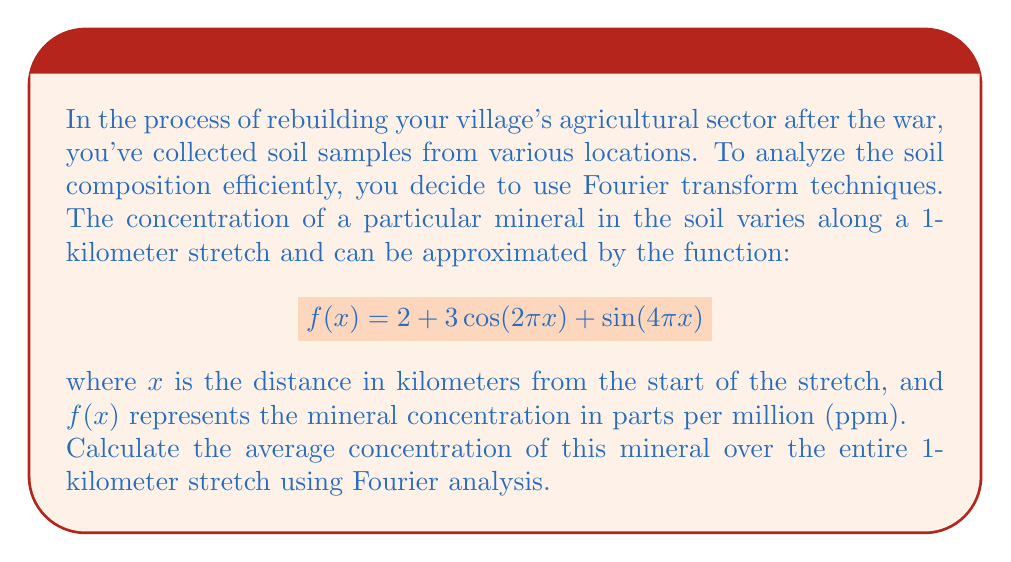Provide a solution to this math problem. To solve this problem, we'll use the properties of Fourier series and the fact that the average value of a function over its period is equal to its constant term (a₀) in the Fourier series.

1) First, let's identify the components of our function:
   $$f(x) = 2 + 3\cos(2\pi x) + \sin(4\pi x)$$

2) This function is already in the form of a Fourier series with:
   - Constant term: $a_0 = 2$
   - Cosine term: $3\cos(2\pi x)$ with frequency $2\pi$
   - Sine term: $\sin(4\pi x)$ with frequency $4\pi$

3) The key property we'll use is that the average value of a periodic function over one period is equal to the constant term in its Fourier series representation.

4) In this case, our function has a period of 1 (kilometer), as $\cos(2\pi x)$ and $\sin(4\pi x)$ both complete full cycles when $x$ increases by 1.

5) Therefore, the average concentration over the 1-kilometer stretch is simply the constant term $a_0 = 2$.

This result makes intuitive sense because the cosine and sine terms oscillate above and below zero, canceling out over a full period, leaving only the constant term to contribute to the average.
Answer: The average concentration of the mineral over the 1-kilometer stretch is 2 ppm. 